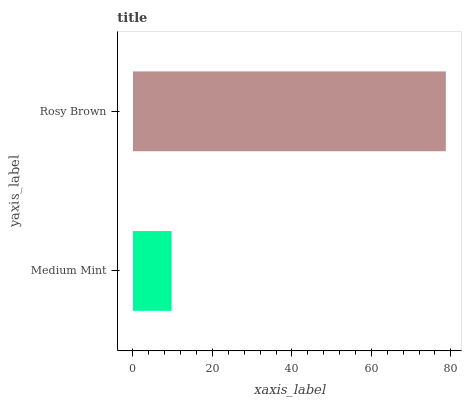Is Medium Mint the minimum?
Answer yes or no. Yes. Is Rosy Brown the maximum?
Answer yes or no. Yes. Is Rosy Brown the minimum?
Answer yes or no. No. Is Rosy Brown greater than Medium Mint?
Answer yes or no. Yes. Is Medium Mint less than Rosy Brown?
Answer yes or no. Yes. Is Medium Mint greater than Rosy Brown?
Answer yes or no. No. Is Rosy Brown less than Medium Mint?
Answer yes or no. No. Is Rosy Brown the high median?
Answer yes or no. Yes. Is Medium Mint the low median?
Answer yes or no. Yes. Is Medium Mint the high median?
Answer yes or no. No. Is Rosy Brown the low median?
Answer yes or no. No. 